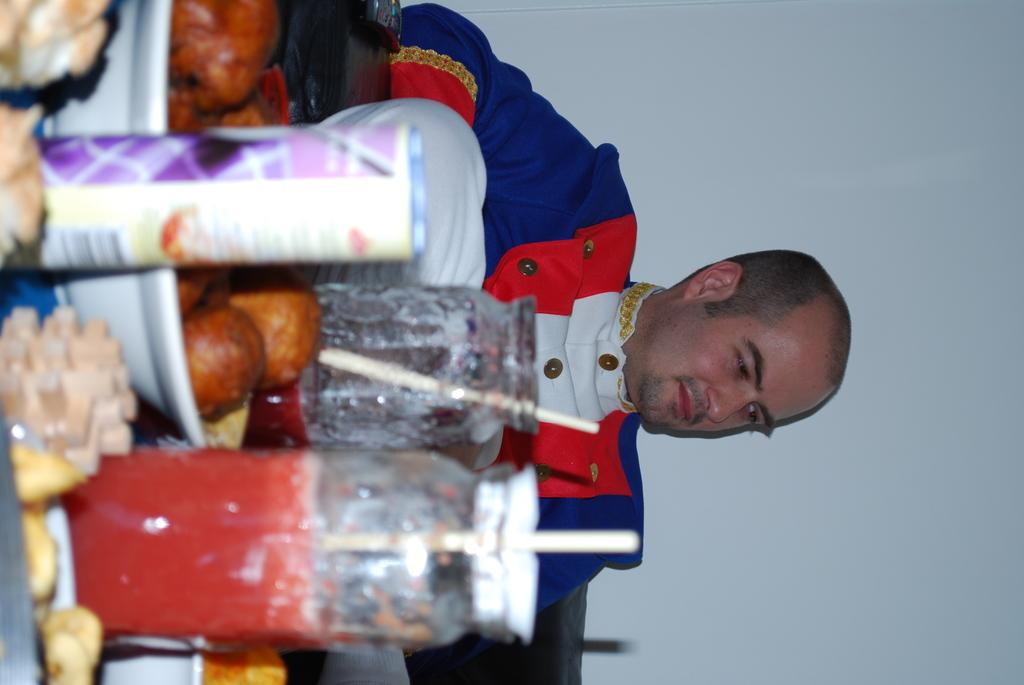What is the man in the image doing? The man is sitting in the image. What type of beverages can be seen in the image? There are bottles with juice in the image. What type of food items are present in the image? There are bowls with food items in the image. What type of insect can be seen crawling on the man's shoulder in the image? There is no insect visible on the man's shoulder in the image. 